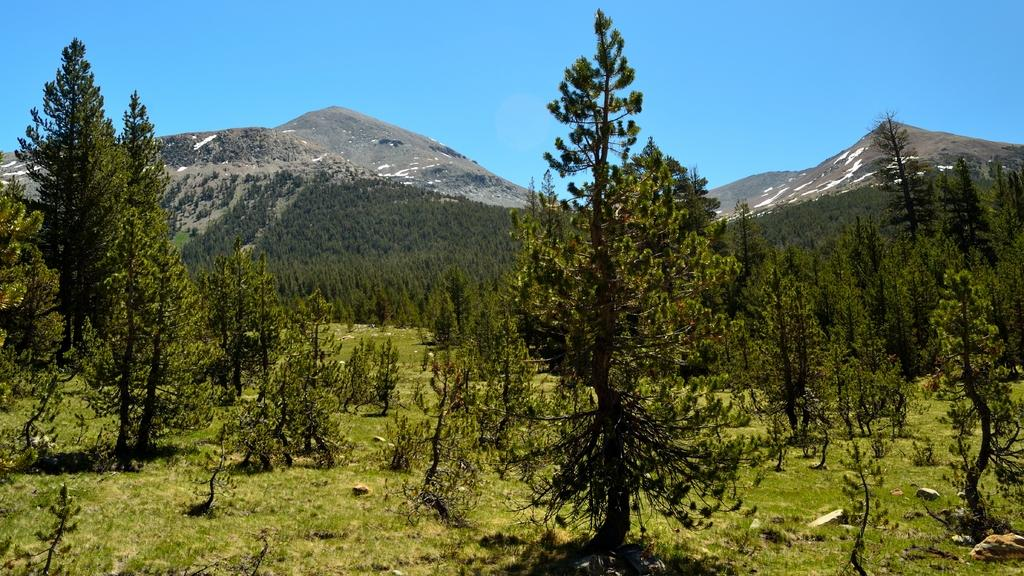What is the dominant color of the land in the image? The land in the image is green. What type of vegetation can be seen in the background of the image? There are trees in the background of the image. What type of geographical feature is visible in the background of the image? There are mountains visible in the background of the image. What is the color of the sky in the image? The sky is blue in the image. What type of pancake is being served on the trees in the image? There are no pancakes present in the image, and the trees are not serving any food. 